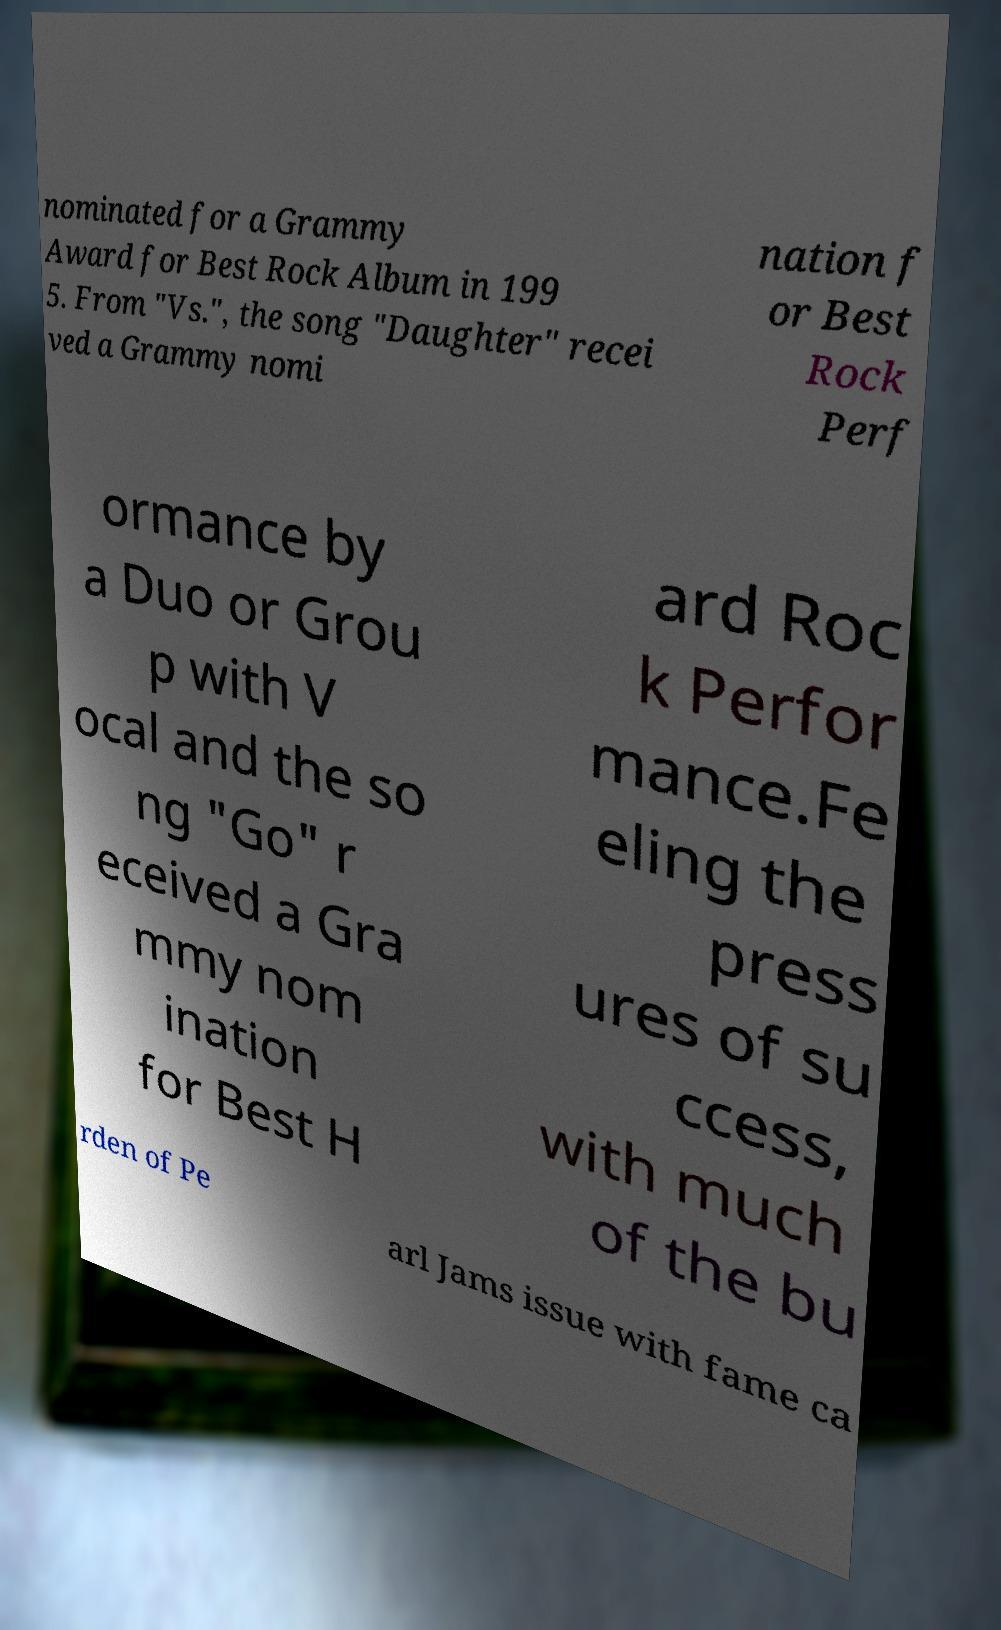Can you read and provide the text displayed in the image?This photo seems to have some interesting text. Can you extract and type it out for me? nominated for a Grammy Award for Best Rock Album in 199 5. From "Vs.", the song "Daughter" recei ved a Grammy nomi nation f or Best Rock Perf ormance by a Duo or Grou p with V ocal and the so ng "Go" r eceived a Gra mmy nom ination for Best H ard Roc k Perfor mance.Fe eling the press ures of su ccess, with much of the bu rden of Pe arl Jams issue with fame ca 